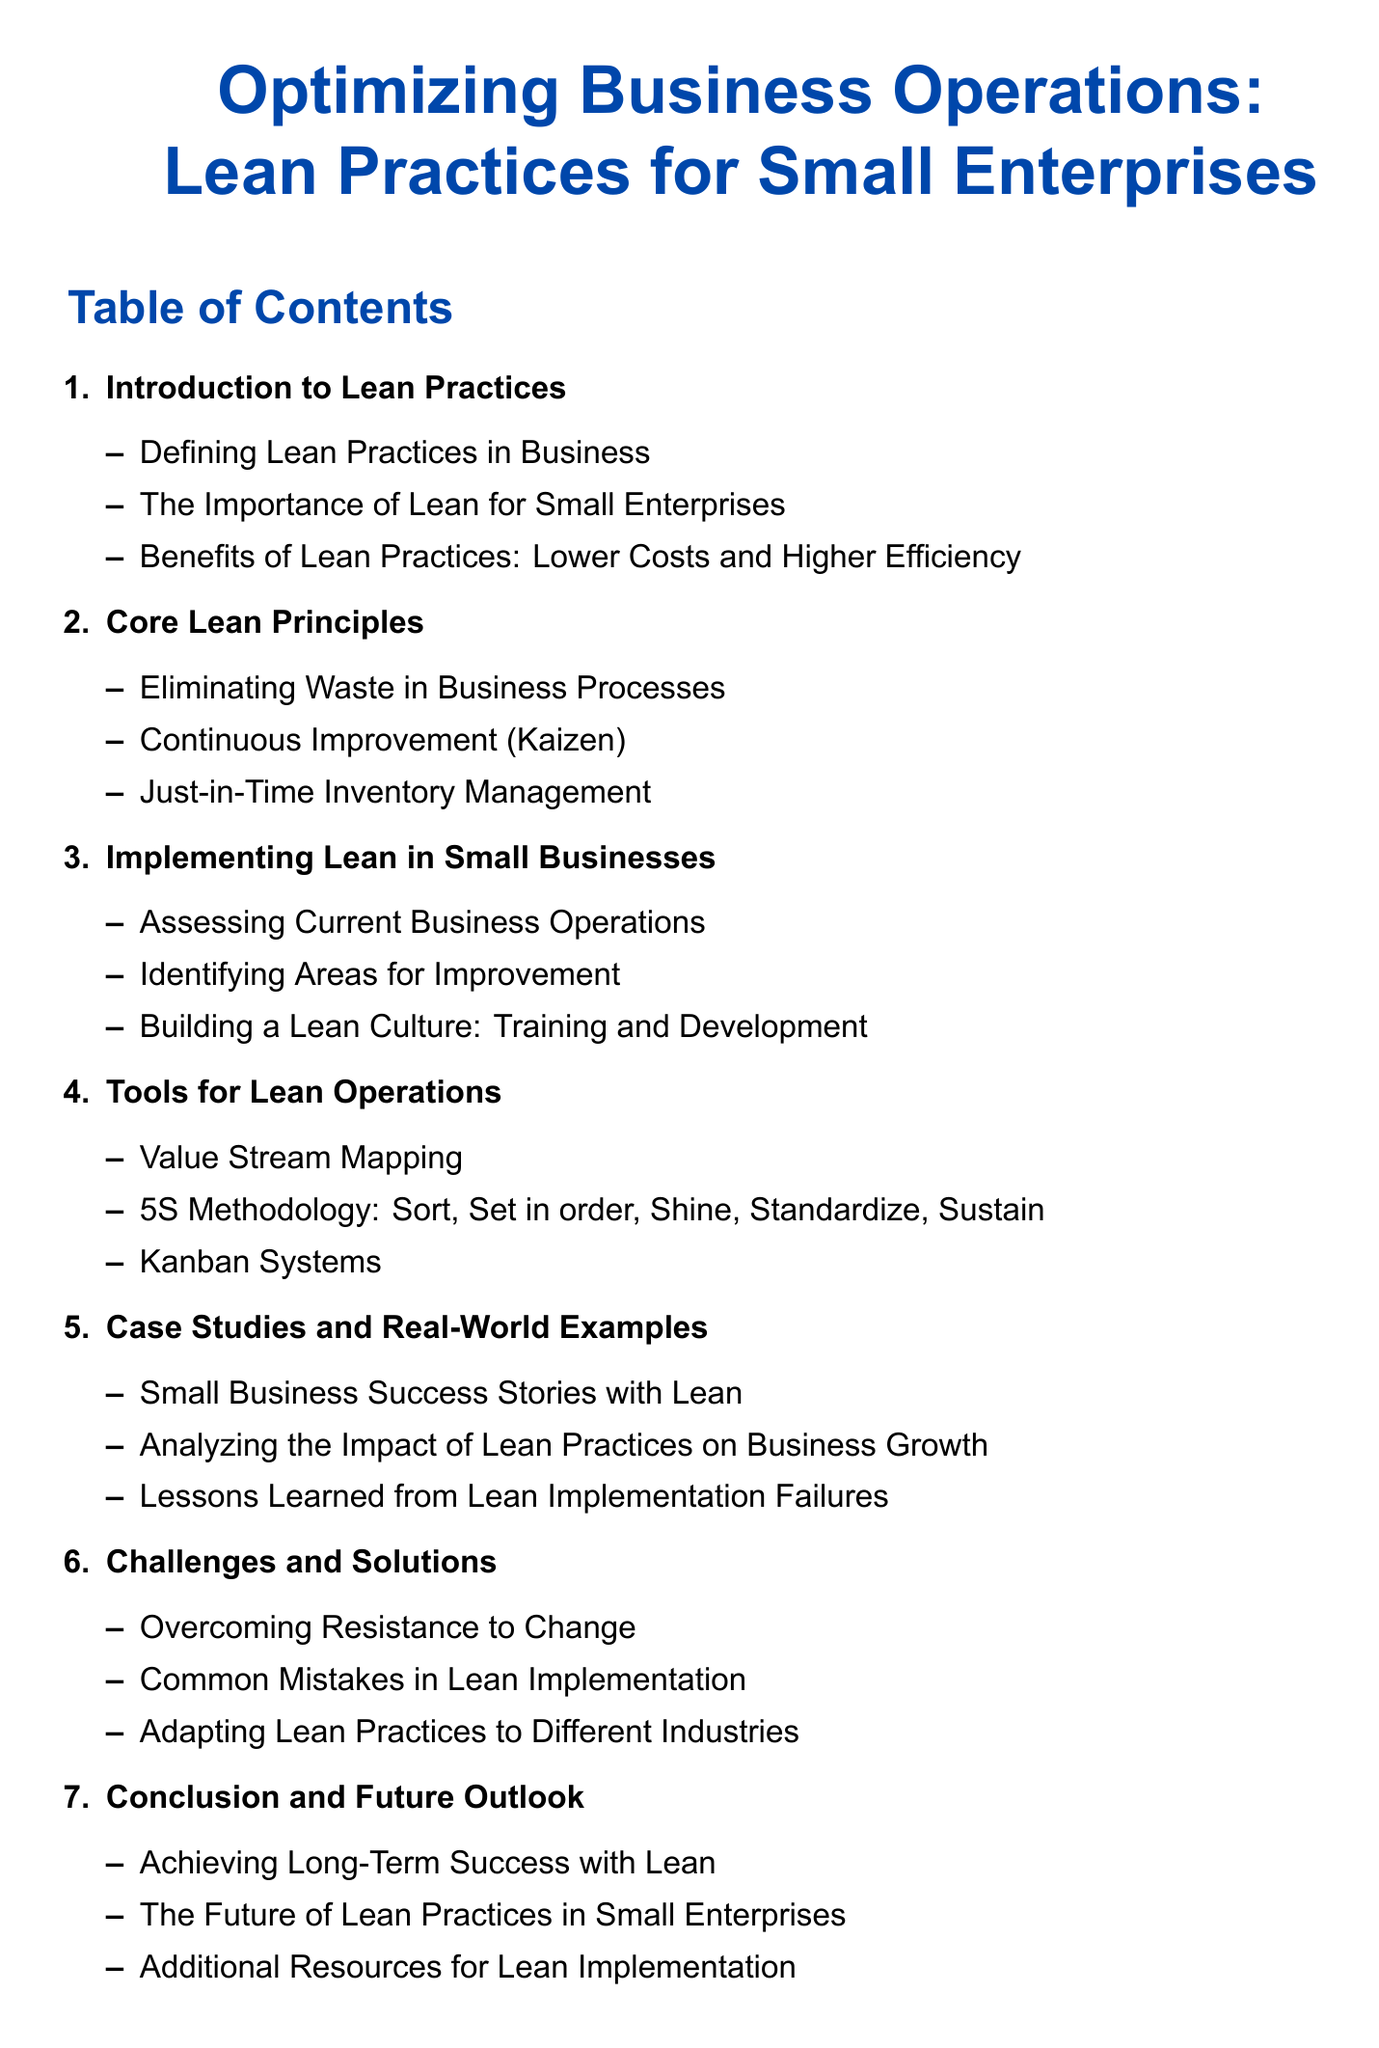What is the title of the document? The title is the first element in the document, indicating the main focus, which is about optimizing business operations through lean practices.
Answer: Optimizing Business Operations: Lean Practices for Small Enterprises How many core lean principles are listed? The number of core lean principles is shown in the section listing under Core Lean Principles in the Table of Contents.
Answer: 3 What is the first tool for lean operations mentioned? The first tool is identified in the list under the Tools for Lean Operations section in the Table of Contents.
Answer: Value Stream Mapping What is the focus of section 6? The title of section 6 summarizes the main topic discussed, which involves discussing various challenges associated with lean practices.
Answer: Challenges and Solutions What type of examples are provided in section 5? The title of section 5 indicates the nature of the content, focusing on practical instances of lean practices in action.
Answer: Case Studies and Real-World Examples How many subsections are in the introduction? The number of subsections under the Introduction to Lean Practices is indicated in the Table of Contents, showing how many specific topics get covered.
Answer: 3 What does Kaizen mean in the context of this document? Kaizen is identified as one of the core lean principles, representing the philosophy of continuous improvement.
Answer: Continuous Improvement Which industry aspects does section 6 adapt lean practices to? The mention of 'different industries' in the context of applying lean practices refers to the adaptability of lean methodologies.
Answer: Different Industries 